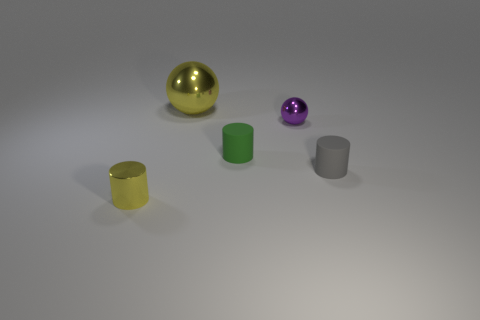Do the large object and the tiny metallic cylinder have the same color?
Ensure brevity in your answer.  Yes. There is a sphere that is on the right side of the green matte thing; is it the same size as the big ball?
Your answer should be compact. No. What number of rubber things are either big yellow objects or large purple cylinders?
Offer a very short reply. 0. There is a metal ball to the left of the tiny green matte cylinder; what size is it?
Ensure brevity in your answer.  Large. Does the tiny purple metal object have the same shape as the tiny yellow thing?
Provide a short and direct response. No. What number of big objects are metal cubes or yellow cylinders?
Keep it short and to the point. 0. There is a green thing; are there any yellow shiny cylinders left of it?
Keep it short and to the point. Yes. Are there the same number of tiny metal cylinders that are on the left side of the small yellow shiny object and brown things?
Make the answer very short. Yes. The other object that is the same shape as the purple thing is what size?
Keep it short and to the point. Large. Do the green object and the yellow object that is in front of the small gray thing have the same shape?
Offer a terse response. Yes. 